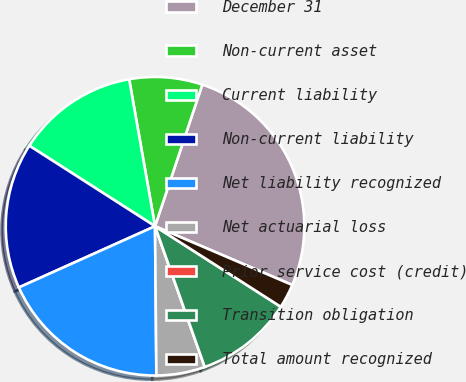Convert chart to OTSL. <chart><loc_0><loc_0><loc_500><loc_500><pie_chart><fcel>December 31<fcel>Non-current asset<fcel>Current liability<fcel>Non-current liability<fcel>Net liability recognized<fcel>Net actuarial loss<fcel>Prior service cost (credit)<fcel>Transition obligation<fcel>Total amount recognized<nl><fcel>26.31%<fcel>7.9%<fcel>13.16%<fcel>15.79%<fcel>18.42%<fcel>5.26%<fcel>0.0%<fcel>10.53%<fcel>2.63%<nl></chart> 